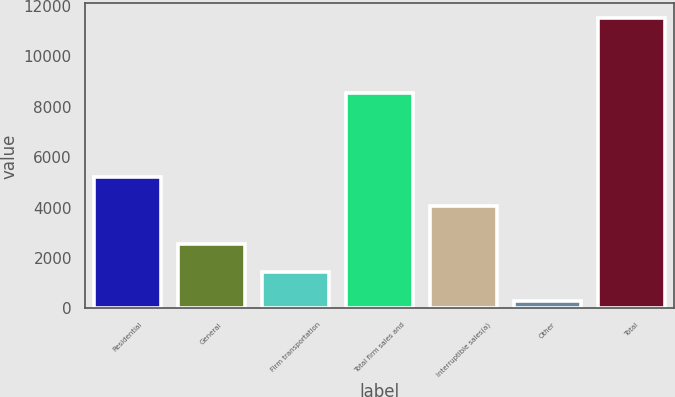Convert chart. <chart><loc_0><loc_0><loc_500><loc_500><bar_chart><fcel>Residential<fcel>General<fcel>Firm transportation<fcel>Total firm sales and<fcel>Interruptible sales(a)<fcel>Other<fcel>Total<nl><fcel>5196.8<fcel>2553.8<fcel>1431<fcel>8532<fcel>4074<fcel>303<fcel>11531<nl></chart> 